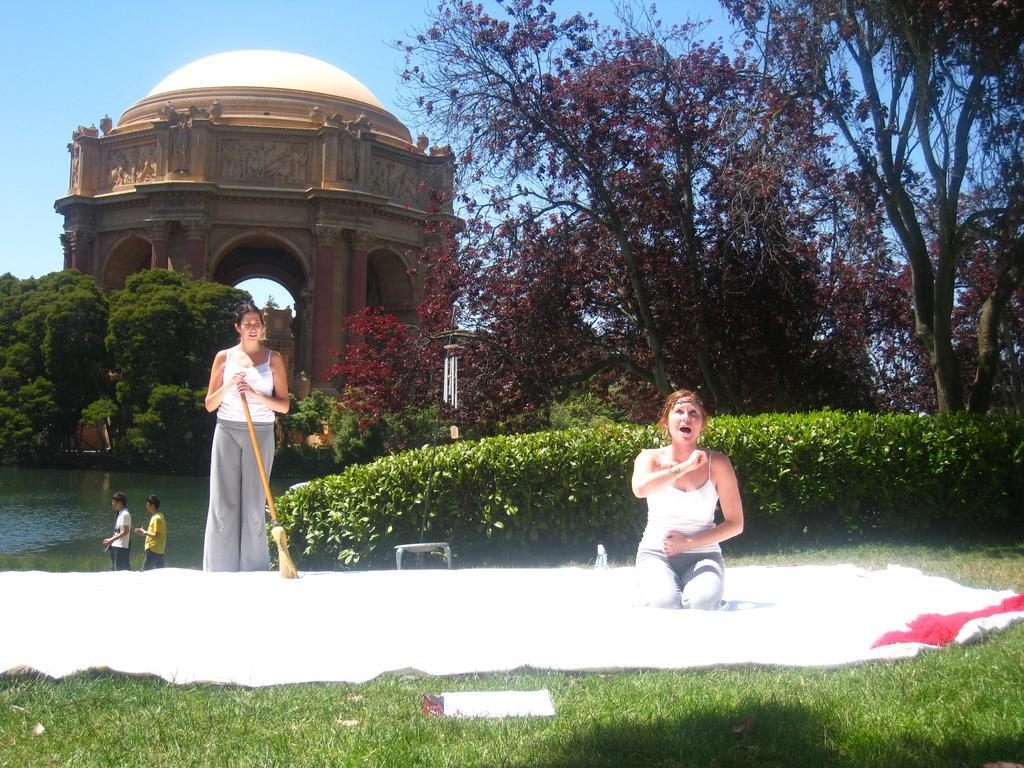In one or two sentences, can you explain what this image depicts? In this image, we can see a person wearing clothes and sitting on knees. There is an another person standing and holding a mop with her hands. There is a cloth on the grass. There are two persons beside the lake. There are some trees and plants in the middle of the image. There is a gateway in the top left of the image. In the background of the image, there is a sky. 